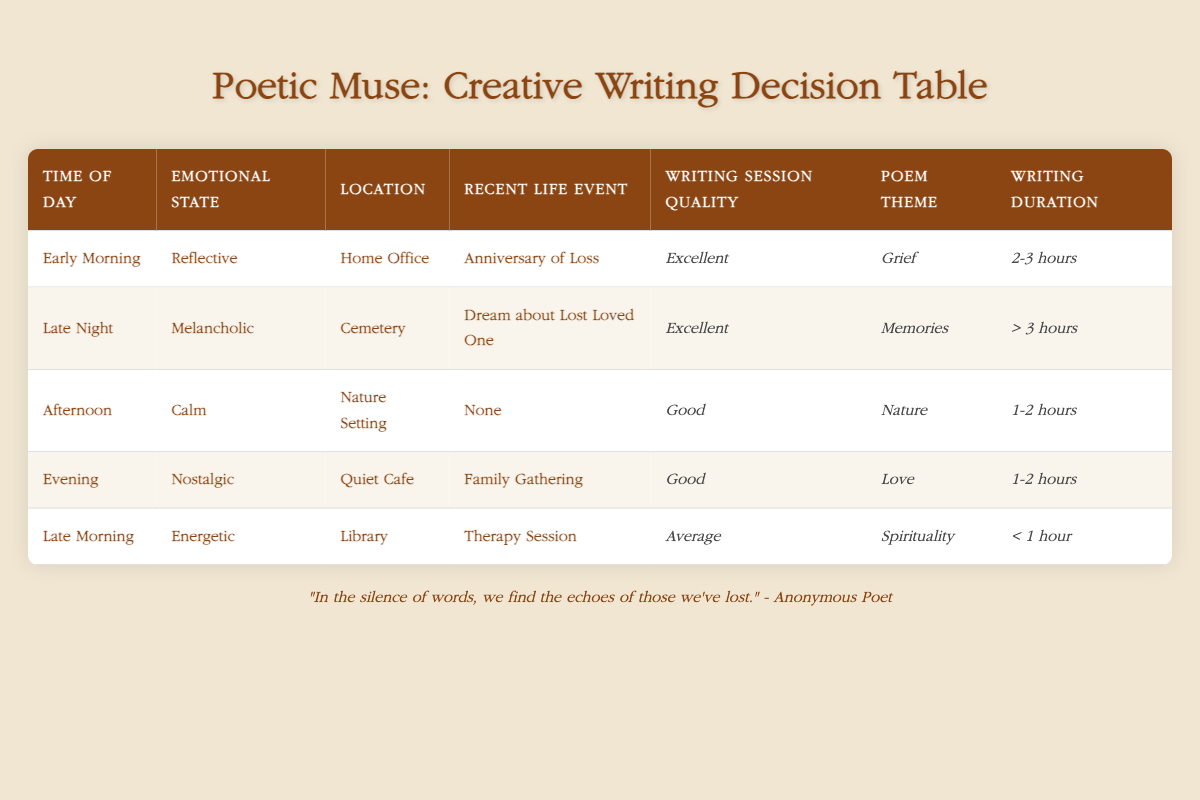What is the writing session quality for a reflective emotional state during early morning at home office? From the table, when the emotional state is reflective and the time of day is early morning at the home office, the writing session quality is listed as excellent.
Answer: Excellent How long is the writing duration when the location is a nature setting and the emotional state is calm? The table specifies that in a nature setting with a calm emotional state, the writing duration is between 1-2 hours.
Answer: 1-2 hours Is it true that a melancholic emotional state during late night in a cemetery leads to writing session quality rated as good? According to the table, a melancholic emotional state during the late night at the cemetery results in an excellent writing session quality, thus this statement is false.
Answer: False What are the potential poem themes for writing sessions with emotional states nostalgic and energetic? For nostalgic emotional states, the poem theme listed is love, while for energetic emotional states, the theme is spirituality. Therefore, the two potential themes are love and spirituality.
Answer: Love and Spirituality Which time of day has the highest writing session quality and what is its corresponding emotional state and recent life event? The highest writing session quality is excellent, which occurs during early morning with a reflective emotional state dealing with an anniversary of loss.
Answer: Excellent, Reflective, Anniversary of Loss 